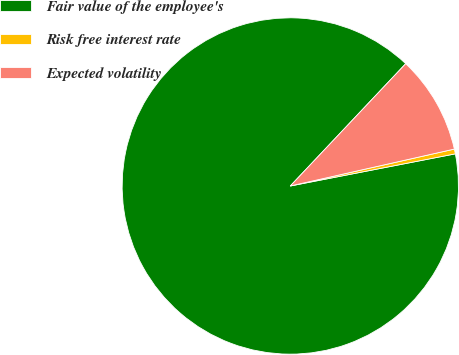<chart> <loc_0><loc_0><loc_500><loc_500><pie_chart><fcel>Fair value of the employee's<fcel>Risk free interest rate<fcel>Expected volatility<nl><fcel>90.1%<fcel>0.46%<fcel>9.44%<nl></chart> 